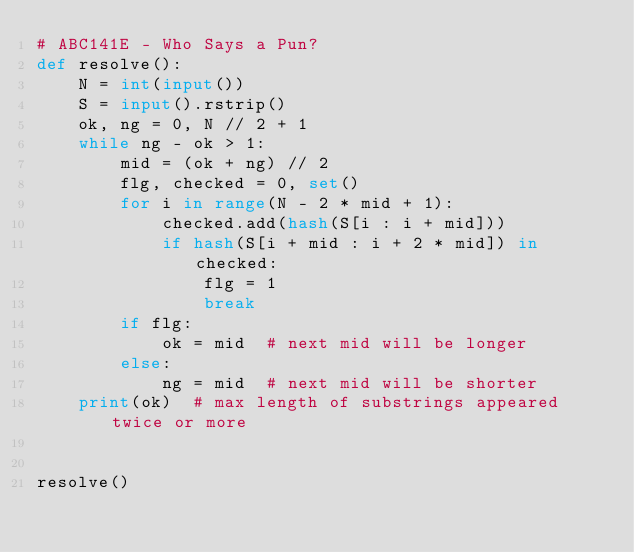Convert code to text. <code><loc_0><loc_0><loc_500><loc_500><_Python_># ABC141E - Who Says a Pun?
def resolve():
    N = int(input())
    S = input().rstrip()
    ok, ng = 0, N // 2 + 1
    while ng - ok > 1:
        mid = (ok + ng) // 2
        flg, checked = 0, set()
        for i in range(N - 2 * mid + 1):
            checked.add(hash(S[i : i + mid]))
            if hash(S[i + mid : i + 2 * mid]) in checked:
                flg = 1
                break
        if flg:
            ok = mid  # next mid will be longer
        else:
            ng = mid  # next mid will be shorter
    print(ok)  # max length of substrings appeared twice or more


resolve()</code> 